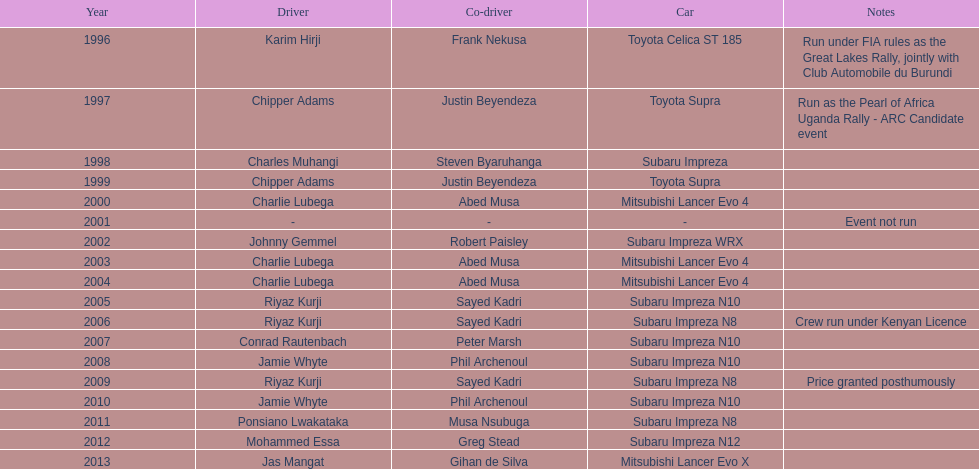How many occasions did charlie lubega serve as a driver? 3. 